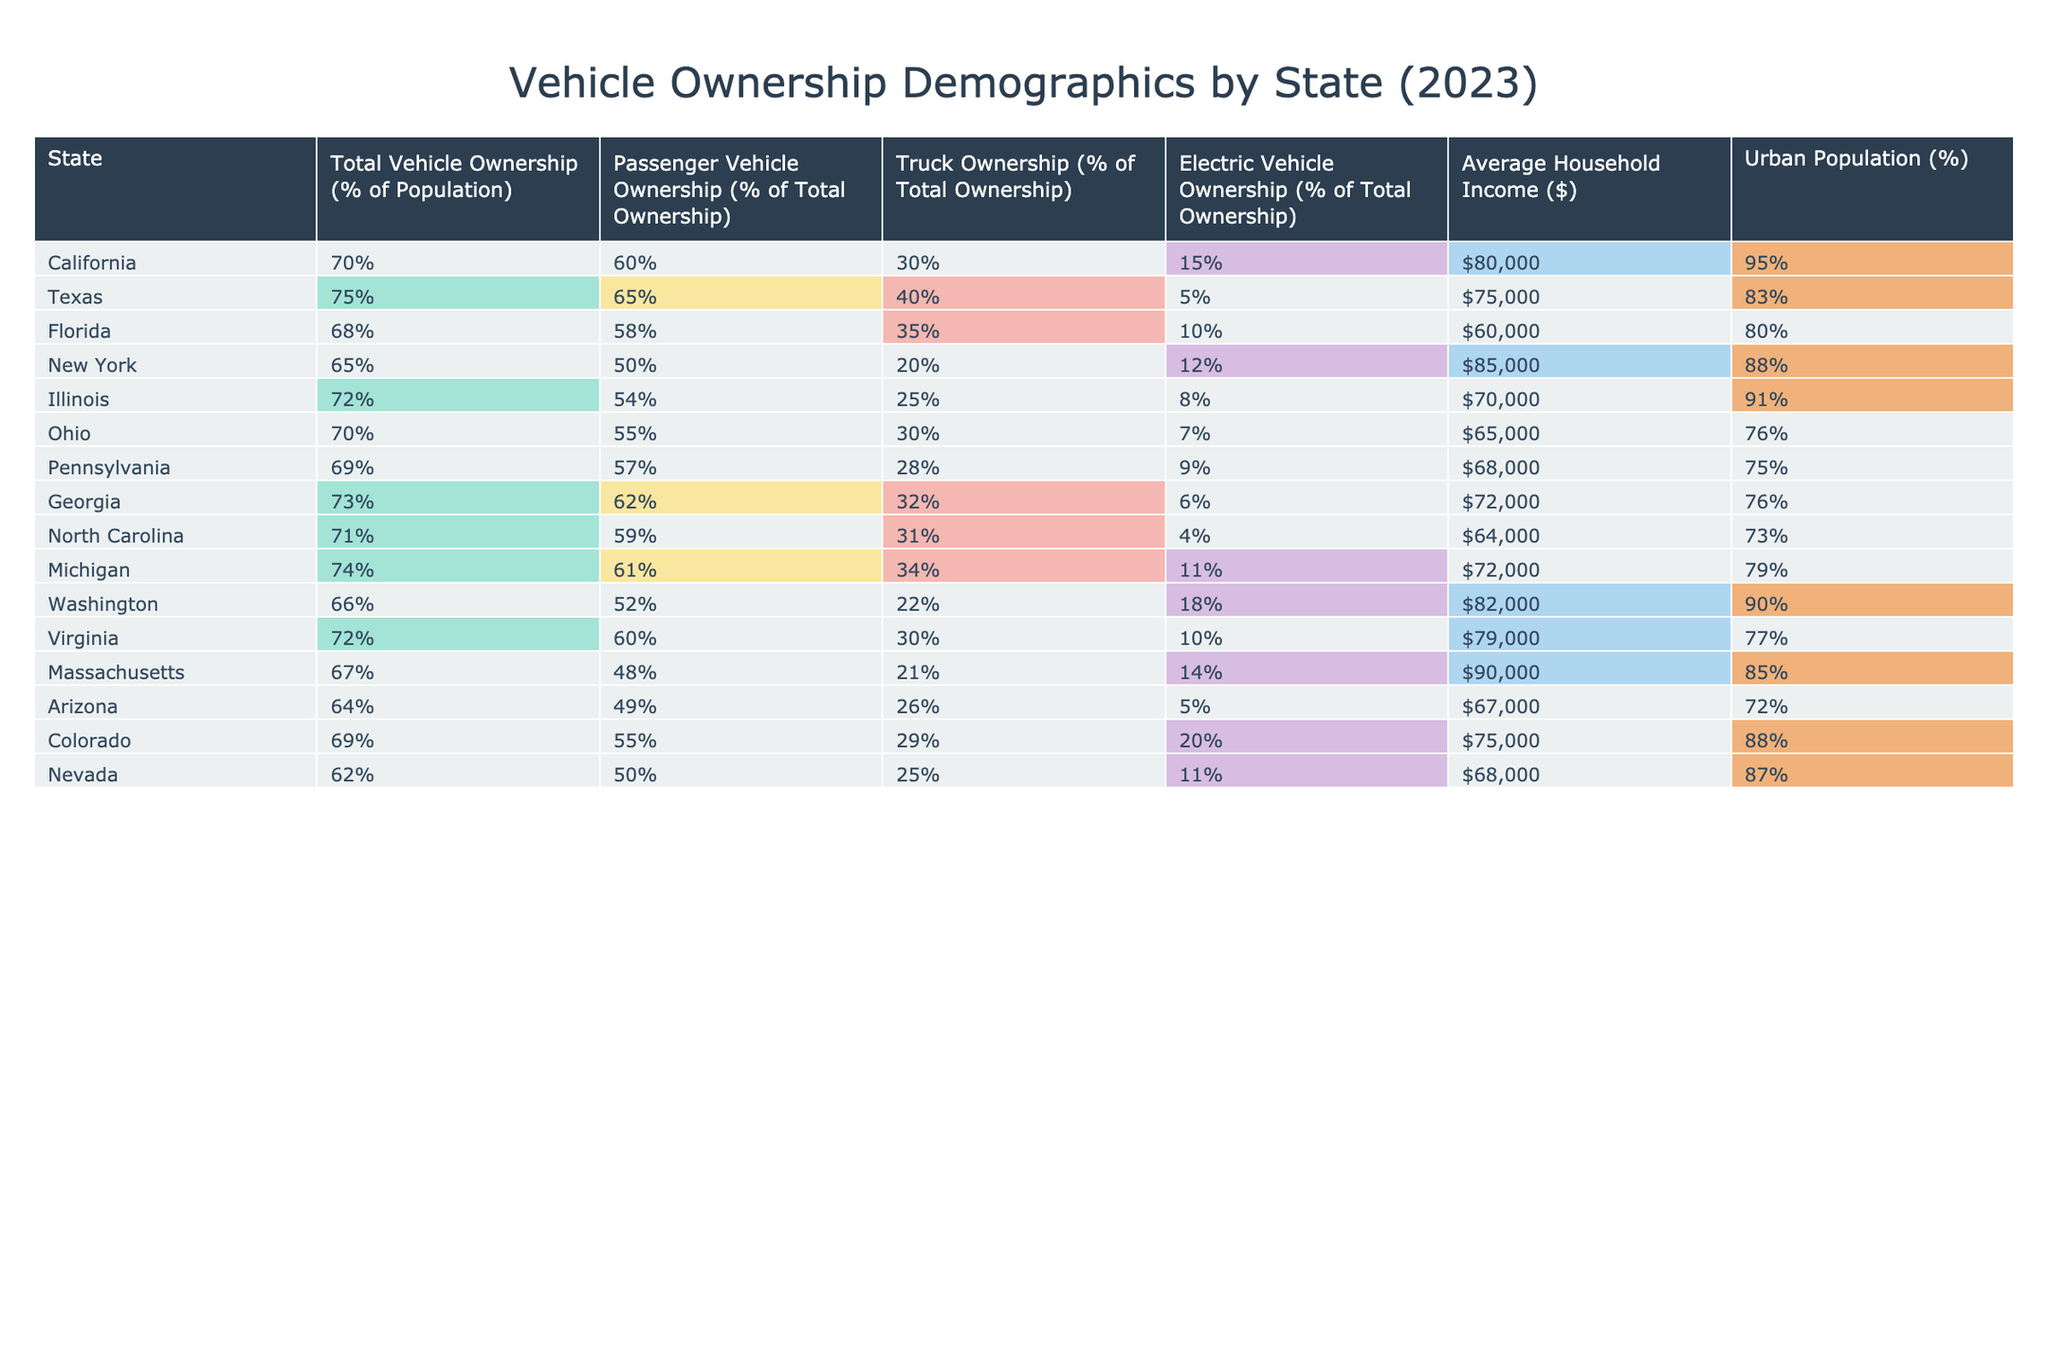What state has the highest total vehicle ownership percentage? By examining the 'Total Vehicle Ownership (% of Population)' column, Texas has the highest percentage at 75%.
Answer: Texas Which state has the lowest electric vehicle ownership percentage? Looking at the 'Electric Vehicle Ownership (% of Total Ownership)' column, Texas has the lowest percentage at 5%.
Answer: Texas What is the average household income in California? The 'Average Household Income ($)' column shows that California's average is $80,000.
Answer: $80,000 Is the urban population percentage higher in Florida than in Pennsylvania? Checking the 'Urban Population (%)' column, Florida has 80% while Pennsylvania has 75%, so 80% is higher.
Answer: Yes How many states have a total vehicle ownership rate greater than 70%? The states with more than 70% total vehicle ownership are Texas, Florida, Illinois, Georgia, Michigan, and California, making a total of 6 states.
Answer: 6 What is the difference in average household income between New York and North Carolina? From the 'Average Household Income ($)' column, New York's average is $85,000 and North Carolina's is $64,000, so the difference is $85,000 - $64,000 = $21,000.
Answer: $21,000 Which state has a higher percentage of truck ownership: Michigan or Virginia? In the 'Truck Ownership (% of Total Ownership)' column, Michigan has 34% and Virginia has 30%, so Michigan has a higher percentage.
Answer: Michigan Calculate the average electric vehicle ownership percentage for the states with urban populations over 80%. The relevant states are California (15%), New York (12%), Illinois (8%), Washington (18%), and Virginia (10%). The average is (15 + 12 + 8 + 18 + 10) / 5 = 63 / 5 = 12.6%.
Answer: 12.6% Which state has the highest truck ownership percentage? By referring to the 'Truck Ownership (% of Total Ownership)' column, Michigan has the highest percentage at 34%.
Answer: Michigan What percentage of total vehicle ownership does Michigan have compared to Florida? Michigan has 74% and Florida has 68%, so Michigan has 74% - 68% = 6% more total vehicle ownership than Florida.
Answer: 6% 